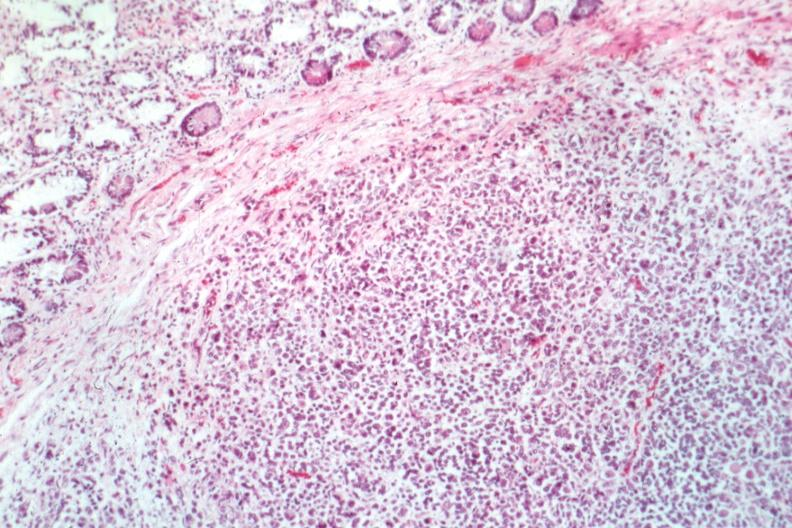s the tumor?
Answer the question using a single word or phrase. Yes 